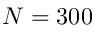<formula> <loc_0><loc_0><loc_500><loc_500>N = 3 0 0</formula> 